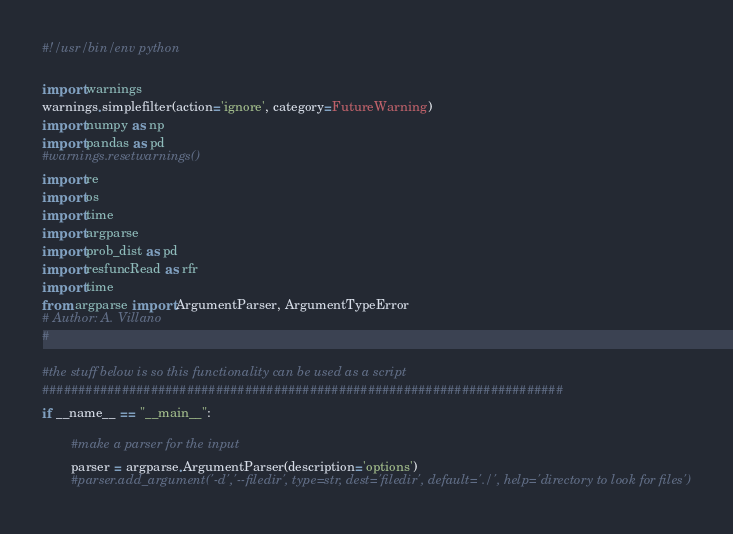<code> <loc_0><loc_0><loc_500><loc_500><_Python_>#!/usr/bin/env python

import warnings
warnings.simplefilter(action='ignore', category=FutureWarning)
import numpy as np
import pandas as pd
#warnings.resetwarnings()
import re
import os
import time
import argparse
import prob_dist as pd
import resfuncRead as rfr
import time
from argparse import ArgumentParser, ArgumentTypeError
# Author: A. Villano
#

#the stuff below is so this functionality can be used as a script
########################################################################
if __name__ == "__main__":

        #make a parser for the input
        parser = argparse.ArgumentParser(description='options')
        #parser.add_argument('-d','--filedir', type=str, dest='filedir', default='./', help='directory to look for files')</code> 